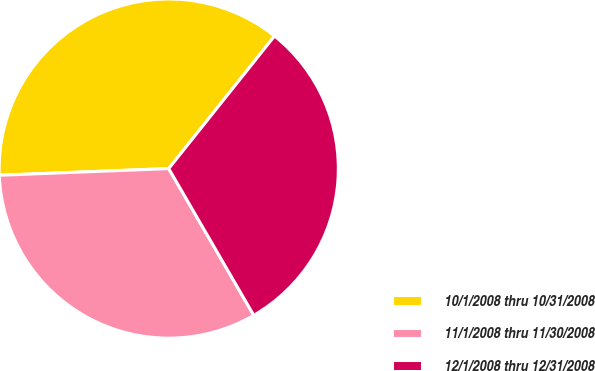<chart> <loc_0><loc_0><loc_500><loc_500><pie_chart><fcel>10/1/2008 thru 10/31/2008<fcel>11/1/2008 thru 11/30/2008<fcel>12/1/2008 thru 12/31/2008<nl><fcel>36.35%<fcel>32.73%<fcel>30.92%<nl></chart> 